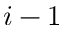<formula> <loc_0><loc_0><loc_500><loc_500>i - 1</formula> 